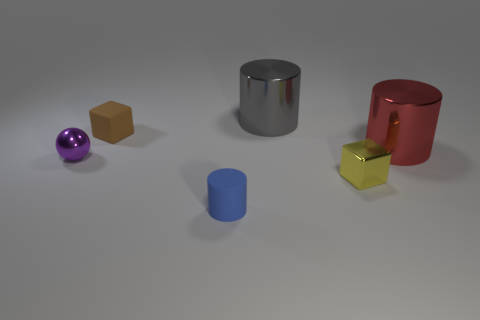How many large objects are purple things or brown cubes?
Offer a very short reply. 0. There is a tiny object that is in front of the brown rubber object and behind the small yellow block; what shape is it?
Make the answer very short. Sphere. Are the tiny cylinder and the purple thing made of the same material?
Provide a short and direct response. No. The metal sphere that is the same size as the blue matte thing is what color?
Your answer should be compact. Purple. The cylinder that is both left of the small metallic block and in front of the brown block is what color?
Your answer should be very brief. Blue. There is a matte thing that is on the left side of the tiny rubber object that is in front of the small object that is to the right of the gray shiny thing; what is its size?
Your answer should be very brief. Small. What is the material of the blue object?
Make the answer very short. Rubber. Is the small yellow cube made of the same material as the big cylinder in front of the small brown block?
Your answer should be very brief. Yes. There is a large metallic cylinder right of the block right of the small blue cylinder; is there a small blue cylinder that is behind it?
Ensure brevity in your answer.  No. What color is the small cylinder?
Ensure brevity in your answer.  Blue. 